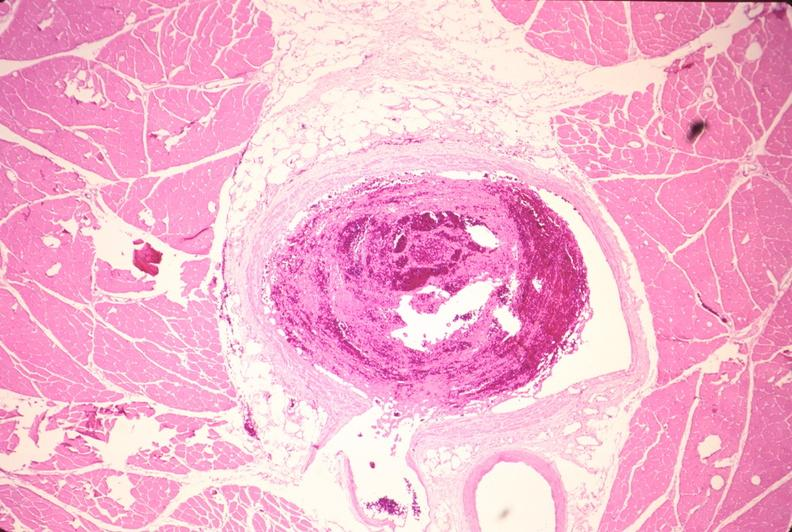does this image show leg veins, thrombus?
Answer the question using a single word or phrase. Yes 